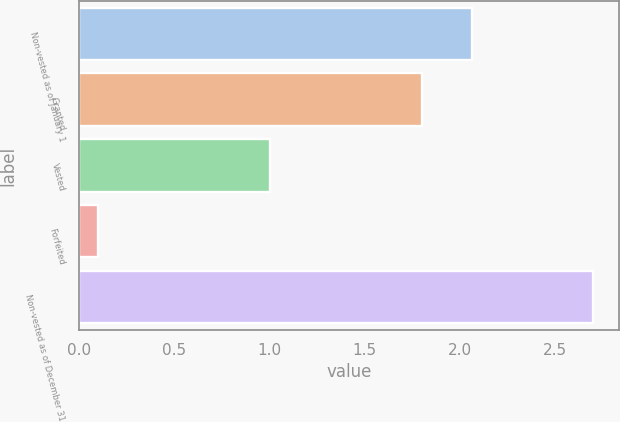Convert chart to OTSL. <chart><loc_0><loc_0><loc_500><loc_500><bar_chart><fcel>Non-vested as of January 1<fcel>Granted<fcel>Vested<fcel>Forfeited<fcel>Non-vested as of December 31<nl><fcel>2.06<fcel>1.8<fcel>1<fcel>0.1<fcel>2.7<nl></chart> 